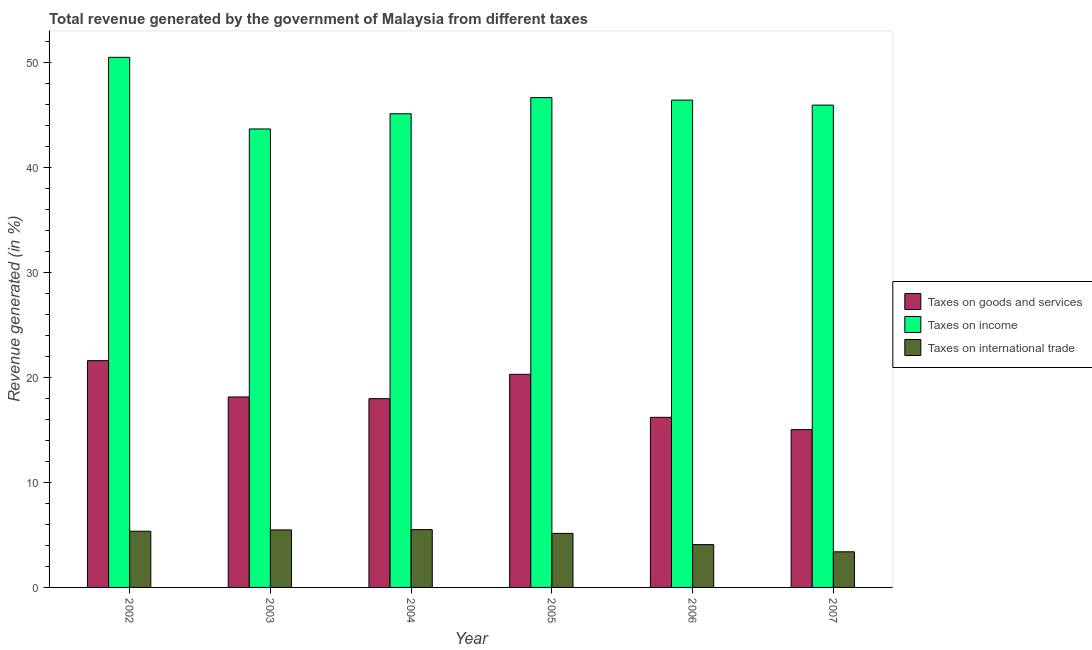How many different coloured bars are there?
Your answer should be very brief. 3. Are the number of bars per tick equal to the number of legend labels?
Your answer should be compact. Yes. Are the number of bars on each tick of the X-axis equal?
Provide a short and direct response. Yes. How many bars are there on the 1st tick from the left?
Your answer should be compact. 3. How many bars are there on the 5th tick from the right?
Offer a terse response. 3. What is the percentage of revenue generated by taxes on income in 2003?
Provide a succinct answer. 43.67. Across all years, what is the maximum percentage of revenue generated by taxes on income?
Your response must be concise. 50.49. Across all years, what is the minimum percentage of revenue generated by taxes on goods and services?
Ensure brevity in your answer.  15.03. In which year was the percentage of revenue generated by taxes on income maximum?
Your answer should be very brief. 2002. In which year was the percentage of revenue generated by taxes on income minimum?
Your response must be concise. 2003. What is the total percentage of revenue generated by taxes on goods and services in the graph?
Your answer should be very brief. 109.26. What is the difference between the percentage of revenue generated by taxes on goods and services in 2005 and that in 2006?
Offer a very short reply. 4.1. What is the difference between the percentage of revenue generated by tax on international trade in 2005 and the percentage of revenue generated by taxes on income in 2002?
Make the answer very short. -0.21. What is the average percentage of revenue generated by taxes on goods and services per year?
Your answer should be very brief. 18.21. In how many years, is the percentage of revenue generated by tax on international trade greater than 34 %?
Make the answer very short. 0. What is the ratio of the percentage of revenue generated by taxes on income in 2003 to that in 2005?
Ensure brevity in your answer.  0.94. Is the difference between the percentage of revenue generated by tax on international trade in 2003 and 2006 greater than the difference between the percentage of revenue generated by taxes on goods and services in 2003 and 2006?
Make the answer very short. No. What is the difference between the highest and the second highest percentage of revenue generated by taxes on income?
Your response must be concise. 3.84. What is the difference between the highest and the lowest percentage of revenue generated by taxes on goods and services?
Keep it short and to the point. 6.57. What does the 1st bar from the left in 2002 represents?
Your answer should be compact. Taxes on goods and services. What does the 1st bar from the right in 2003 represents?
Your answer should be very brief. Taxes on international trade. Is it the case that in every year, the sum of the percentage of revenue generated by taxes on goods and services and percentage of revenue generated by taxes on income is greater than the percentage of revenue generated by tax on international trade?
Give a very brief answer. Yes. How many bars are there?
Provide a succinct answer. 18. Are all the bars in the graph horizontal?
Your response must be concise. No. How many years are there in the graph?
Offer a terse response. 6. What is the difference between two consecutive major ticks on the Y-axis?
Offer a terse response. 10. Are the values on the major ticks of Y-axis written in scientific E-notation?
Make the answer very short. No. Does the graph contain grids?
Your answer should be very brief. No. How many legend labels are there?
Keep it short and to the point. 3. How are the legend labels stacked?
Provide a short and direct response. Vertical. What is the title of the graph?
Your answer should be very brief. Total revenue generated by the government of Malaysia from different taxes. What is the label or title of the X-axis?
Ensure brevity in your answer.  Year. What is the label or title of the Y-axis?
Your response must be concise. Revenue generated (in %). What is the Revenue generated (in %) of Taxes on goods and services in 2002?
Give a very brief answer. 21.6. What is the Revenue generated (in %) of Taxes on income in 2002?
Ensure brevity in your answer.  50.49. What is the Revenue generated (in %) of Taxes on international trade in 2002?
Provide a short and direct response. 5.35. What is the Revenue generated (in %) of Taxes on goods and services in 2003?
Offer a very short reply. 18.14. What is the Revenue generated (in %) in Taxes on income in 2003?
Your answer should be very brief. 43.67. What is the Revenue generated (in %) in Taxes on international trade in 2003?
Keep it short and to the point. 5.48. What is the Revenue generated (in %) of Taxes on goods and services in 2004?
Ensure brevity in your answer.  17.98. What is the Revenue generated (in %) in Taxes on income in 2004?
Provide a short and direct response. 45.12. What is the Revenue generated (in %) in Taxes on international trade in 2004?
Offer a terse response. 5.51. What is the Revenue generated (in %) in Taxes on goods and services in 2005?
Your answer should be compact. 20.3. What is the Revenue generated (in %) of Taxes on income in 2005?
Provide a succinct answer. 46.66. What is the Revenue generated (in %) of Taxes on international trade in 2005?
Your answer should be very brief. 5.15. What is the Revenue generated (in %) in Taxes on goods and services in 2006?
Offer a terse response. 16.2. What is the Revenue generated (in %) of Taxes on income in 2006?
Your answer should be compact. 46.42. What is the Revenue generated (in %) of Taxes on international trade in 2006?
Offer a very short reply. 4.08. What is the Revenue generated (in %) in Taxes on goods and services in 2007?
Give a very brief answer. 15.03. What is the Revenue generated (in %) in Taxes on income in 2007?
Keep it short and to the point. 45.94. What is the Revenue generated (in %) of Taxes on international trade in 2007?
Make the answer very short. 3.39. Across all years, what is the maximum Revenue generated (in %) in Taxes on goods and services?
Make the answer very short. 21.6. Across all years, what is the maximum Revenue generated (in %) in Taxes on income?
Provide a succinct answer. 50.49. Across all years, what is the maximum Revenue generated (in %) of Taxes on international trade?
Your response must be concise. 5.51. Across all years, what is the minimum Revenue generated (in %) in Taxes on goods and services?
Offer a very short reply. 15.03. Across all years, what is the minimum Revenue generated (in %) in Taxes on income?
Provide a short and direct response. 43.67. Across all years, what is the minimum Revenue generated (in %) in Taxes on international trade?
Your answer should be very brief. 3.39. What is the total Revenue generated (in %) in Taxes on goods and services in the graph?
Offer a terse response. 109.26. What is the total Revenue generated (in %) in Taxes on income in the graph?
Provide a short and direct response. 278.29. What is the total Revenue generated (in %) of Taxes on international trade in the graph?
Your answer should be very brief. 28.96. What is the difference between the Revenue generated (in %) in Taxes on goods and services in 2002 and that in 2003?
Your answer should be very brief. 3.46. What is the difference between the Revenue generated (in %) in Taxes on income in 2002 and that in 2003?
Keep it short and to the point. 6.82. What is the difference between the Revenue generated (in %) in Taxes on international trade in 2002 and that in 2003?
Offer a terse response. -0.13. What is the difference between the Revenue generated (in %) in Taxes on goods and services in 2002 and that in 2004?
Offer a terse response. 3.62. What is the difference between the Revenue generated (in %) of Taxes on income in 2002 and that in 2004?
Your answer should be compact. 5.38. What is the difference between the Revenue generated (in %) in Taxes on international trade in 2002 and that in 2004?
Your answer should be very brief. -0.15. What is the difference between the Revenue generated (in %) in Taxes on goods and services in 2002 and that in 2005?
Your answer should be very brief. 1.3. What is the difference between the Revenue generated (in %) in Taxes on income in 2002 and that in 2005?
Your answer should be compact. 3.84. What is the difference between the Revenue generated (in %) of Taxes on international trade in 2002 and that in 2005?
Offer a terse response. 0.21. What is the difference between the Revenue generated (in %) of Taxes on goods and services in 2002 and that in 2006?
Provide a succinct answer. 5.4. What is the difference between the Revenue generated (in %) of Taxes on income in 2002 and that in 2006?
Make the answer very short. 4.07. What is the difference between the Revenue generated (in %) of Taxes on international trade in 2002 and that in 2006?
Your answer should be compact. 1.27. What is the difference between the Revenue generated (in %) of Taxes on goods and services in 2002 and that in 2007?
Provide a short and direct response. 6.57. What is the difference between the Revenue generated (in %) in Taxes on income in 2002 and that in 2007?
Keep it short and to the point. 4.55. What is the difference between the Revenue generated (in %) of Taxes on international trade in 2002 and that in 2007?
Provide a short and direct response. 1.96. What is the difference between the Revenue generated (in %) of Taxes on goods and services in 2003 and that in 2004?
Offer a very short reply. 0.16. What is the difference between the Revenue generated (in %) in Taxes on income in 2003 and that in 2004?
Your response must be concise. -1.45. What is the difference between the Revenue generated (in %) of Taxes on international trade in 2003 and that in 2004?
Provide a short and direct response. -0.03. What is the difference between the Revenue generated (in %) of Taxes on goods and services in 2003 and that in 2005?
Offer a terse response. -2.16. What is the difference between the Revenue generated (in %) of Taxes on income in 2003 and that in 2005?
Provide a succinct answer. -2.99. What is the difference between the Revenue generated (in %) of Taxes on international trade in 2003 and that in 2005?
Keep it short and to the point. 0.33. What is the difference between the Revenue generated (in %) in Taxes on goods and services in 2003 and that in 2006?
Make the answer very short. 1.94. What is the difference between the Revenue generated (in %) of Taxes on income in 2003 and that in 2006?
Your response must be concise. -2.75. What is the difference between the Revenue generated (in %) in Taxes on international trade in 2003 and that in 2006?
Make the answer very short. 1.4. What is the difference between the Revenue generated (in %) in Taxes on goods and services in 2003 and that in 2007?
Your answer should be very brief. 3.11. What is the difference between the Revenue generated (in %) in Taxes on income in 2003 and that in 2007?
Offer a very short reply. -2.27. What is the difference between the Revenue generated (in %) of Taxes on international trade in 2003 and that in 2007?
Make the answer very short. 2.09. What is the difference between the Revenue generated (in %) in Taxes on goods and services in 2004 and that in 2005?
Your answer should be very brief. -2.32. What is the difference between the Revenue generated (in %) in Taxes on income in 2004 and that in 2005?
Your response must be concise. -1.54. What is the difference between the Revenue generated (in %) of Taxes on international trade in 2004 and that in 2005?
Ensure brevity in your answer.  0.36. What is the difference between the Revenue generated (in %) of Taxes on goods and services in 2004 and that in 2006?
Offer a terse response. 1.78. What is the difference between the Revenue generated (in %) of Taxes on income in 2004 and that in 2006?
Provide a succinct answer. -1.3. What is the difference between the Revenue generated (in %) of Taxes on international trade in 2004 and that in 2006?
Offer a terse response. 1.43. What is the difference between the Revenue generated (in %) of Taxes on goods and services in 2004 and that in 2007?
Give a very brief answer. 2.95. What is the difference between the Revenue generated (in %) of Taxes on income in 2004 and that in 2007?
Your answer should be very brief. -0.82. What is the difference between the Revenue generated (in %) of Taxes on international trade in 2004 and that in 2007?
Offer a terse response. 2.11. What is the difference between the Revenue generated (in %) in Taxes on goods and services in 2005 and that in 2006?
Your answer should be very brief. 4.1. What is the difference between the Revenue generated (in %) of Taxes on income in 2005 and that in 2006?
Keep it short and to the point. 0.24. What is the difference between the Revenue generated (in %) of Taxes on international trade in 2005 and that in 2006?
Your answer should be very brief. 1.07. What is the difference between the Revenue generated (in %) in Taxes on goods and services in 2005 and that in 2007?
Offer a terse response. 5.27. What is the difference between the Revenue generated (in %) of Taxes on income in 2005 and that in 2007?
Make the answer very short. 0.72. What is the difference between the Revenue generated (in %) of Taxes on international trade in 2005 and that in 2007?
Keep it short and to the point. 1.75. What is the difference between the Revenue generated (in %) in Taxes on goods and services in 2006 and that in 2007?
Offer a very short reply. 1.17. What is the difference between the Revenue generated (in %) of Taxes on income in 2006 and that in 2007?
Your answer should be compact. 0.48. What is the difference between the Revenue generated (in %) in Taxes on international trade in 2006 and that in 2007?
Provide a short and direct response. 0.69. What is the difference between the Revenue generated (in %) in Taxes on goods and services in 2002 and the Revenue generated (in %) in Taxes on income in 2003?
Your answer should be very brief. -22.07. What is the difference between the Revenue generated (in %) in Taxes on goods and services in 2002 and the Revenue generated (in %) in Taxes on international trade in 2003?
Provide a short and direct response. 16.12. What is the difference between the Revenue generated (in %) of Taxes on income in 2002 and the Revenue generated (in %) of Taxes on international trade in 2003?
Provide a succinct answer. 45.01. What is the difference between the Revenue generated (in %) in Taxes on goods and services in 2002 and the Revenue generated (in %) in Taxes on income in 2004?
Provide a short and direct response. -23.52. What is the difference between the Revenue generated (in %) in Taxes on goods and services in 2002 and the Revenue generated (in %) in Taxes on international trade in 2004?
Provide a short and direct response. 16.09. What is the difference between the Revenue generated (in %) of Taxes on income in 2002 and the Revenue generated (in %) of Taxes on international trade in 2004?
Offer a very short reply. 44.98. What is the difference between the Revenue generated (in %) of Taxes on goods and services in 2002 and the Revenue generated (in %) of Taxes on income in 2005?
Offer a very short reply. -25.06. What is the difference between the Revenue generated (in %) of Taxes on goods and services in 2002 and the Revenue generated (in %) of Taxes on international trade in 2005?
Your answer should be very brief. 16.45. What is the difference between the Revenue generated (in %) in Taxes on income in 2002 and the Revenue generated (in %) in Taxes on international trade in 2005?
Keep it short and to the point. 45.35. What is the difference between the Revenue generated (in %) of Taxes on goods and services in 2002 and the Revenue generated (in %) of Taxes on income in 2006?
Your response must be concise. -24.82. What is the difference between the Revenue generated (in %) of Taxes on goods and services in 2002 and the Revenue generated (in %) of Taxes on international trade in 2006?
Your response must be concise. 17.52. What is the difference between the Revenue generated (in %) in Taxes on income in 2002 and the Revenue generated (in %) in Taxes on international trade in 2006?
Offer a terse response. 46.41. What is the difference between the Revenue generated (in %) in Taxes on goods and services in 2002 and the Revenue generated (in %) in Taxes on income in 2007?
Make the answer very short. -24.34. What is the difference between the Revenue generated (in %) in Taxes on goods and services in 2002 and the Revenue generated (in %) in Taxes on international trade in 2007?
Offer a very short reply. 18.21. What is the difference between the Revenue generated (in %) in Taxes on income in 2002 and the Revenue generated (in %) in Taxes on international trade in 2007?
Offer a terse response. 47.1. What is the difference between the Revenue generated (in %) of Taxes on goods and services in 2003 and the Revenue generated (in %) of Taxes on income in 2004?
Make the answer very short. -26.97. What is the difference between the Revenue generated (in %) of Taxes on goods and services in 2003 and the Revenue generated (in %) of Taxes on international trade in 2004?
Provide a succinct answer. 12.63. What is the difference between the Revenue generated (in %) in Taxes on income in 2003 and the Revenue generated (in %) in Taxes on international trade in 2004?
Make the answer very short. 38.16. What is the difference between the Revenue generated (in %) of Taxes on goods and services in 2003 and the Revenue generated (in %) of Taxes on income in 2005?
Provide a short and direct response. -28.51. What is the difference between the Revenue generated (in %) of Taxes on goods and services in 2003 and the Revenue generated (in %) of Taxes on international trade in 2005?
Give a very brief answer. 13. What is the difference between the Revenue generated (in %) in Taxes on income in 2003 and the Revenue generated (in %) in Taxes on international trade in 2005?
Ensure brevity in your answer.  38.52. What is the difference between the Revenue generated (in %) of Taxes on goods and services in 2003 and the Revenue generated (in %) of Taxes on income in 2006?
Provide a succinct answer. -28.28. What is the difference between the Revenue generated (in %) in Taxes on goods and services in 2003 and the Revenue generated (in %) in Taxes on international trade in 2006?
Your answer should be compact. 14.06. What is the difference between the Revenue generated (in %) in Taxes on income in 2003 and the Revenue generated (in %) in Taxes on international trade in 2006?
Offer a very short reply. 39.59. What is the difference between the Revenue generated (in %) of Taxes on goods and services in 2003 and the Revenue generated (in %) of Taxes on income in 2007?
Keep it short and to the point. -27.8. What is the difference between the Revenue generated (in %) in Taxes on goods and services in 2003 and the Revenue generated (in %) in Taxes on international trade in 2007?
Offer a very short reply. 14.75. What is the difference between the Revenue generated (in %) of Taxes on income in 2003 and the Revenue generated (in %) of Taxes on international trade in 2007?
Your response must be concise. 40.27. What is the difference between the Revenue generated (in %) in Taxes on goods and services in 2004 and the Revenue generated (in %) in Taxes on income in 2005?
Provide a succinct answer. -28.67. What is the difference between the Revenue generated (in %) in Taxes on goods and services in 2004 and the Revenue generated (in %) in Taxes on international trade in 2005?
Your response must be concise. 12.84. What is the difference between the Revenue generated (in %) of Taxes on income in 2004 and the Revenue generated (in %) of Taxes on international trade in 2005?
Ensure brevity in your answer.  39.97. What is the difference between the Revenue generated (in %) in Taxes on goods and services in 2004 and the Revenue generated (in %) in Taxes on income in 2006?
Your response must be concise. -28.44. What is the difference between the Revenue generated (in %) in Taxes on goods and services in 2004 and the Revenue generated (in %) in Taxes on international trade in 2006?
Your answer should be very brief. 13.9. What is the difference between the Revenue generated (in %) of Taxes on income in 2004 and the Revenue generated (in %) of Taxes on international trade in 2006?
Give a very brief answer. 41.04. What is the difference between the Revenue generated (in %) in Taxes on goods and services in 2004 and the Revenue generated (in %) in Taxes on income in 2007?
Give a very brief answer. -27.96. What is the difference between the Revenue generated (in %) in Taxes on goods and services in 2004 and the Revenue generated (in %) in Taxes on international trade in 2007?
Give a very brief answer. 14.59. What is the difference between the Revenue generated (in %) of Taxes on income in 2004 and the Revenue generated (in %) of Taxes on international trade in 2007?
Provide a succinct answer. 41.72. What is the difference between the Revenue generated (in %) in Taxes on goods and services in 2005 and the Revenue generated (in %) in Taxes on income in 2006?
Your answer should be very brief. -26.12. What is the difference between the Revenue generated (in %) of Taxes on goods and services in 2005 and the Revenue generated (in %) of Taxes on international trade in 2006?
Provide a short and direct response. 16.22. What is the difference between the Revenue generated (in %) of Taxes on income in 2005 and the Revenue generated (in %) of Taxes on international trade in 2006?
Keep it short and to the point. 42.58. What is the difference between the Revenue generated (in %) in Taxes on goods and services in 2005 and the Revenue generated (in %) in Taxes on income in 2007?
Make the answer very short. -25.64. What is the difference between the Revenue generated (in %) in Taxes on goods and services in 2005 and the Revenue generated (in %) in Taxes on international trade in 2007?
Ensure brevity in your answer.  16.91. What is the difference between the Revenue generated (in %) of Taxes on income in 2005 and the Revenue generated (in %) of Taxes on international trade in 2007?
Provide a succinct answer. 43.26. What is the difference between the Revenue generated (in %) in Taxes on goods and services in 2006 and the Revenue generated (in %) in Taxes on income in 2007?
Offer a very short reply. -29.74. What is the difference between the Revenue generated (in %) in Taxes on goods and services in 2006 and the Revenue generated (in %) in Taxes on international trade in 2007?
Ensure brevity in your answer.  12.81. What is the difference between the Revenue generated (in %) of Taxes on income in 2006 and the Revenue generated (in %) of Taxes on international trade in 2007?
Provide a short and direct response. 43.02. What is the average Revenue generated (in %) of Taxes on goods and services per year?
Ensure brevity in your answer.  18.21. What is the average Revenue generated (in %) of Taxes on income per year?
Provide a succinct answer. 46.38. What is the average Revenue generated (in %) of Taxes on international trade per year?
Your answer should be very brief. 4.83. In the year 2002, what is the difference between the Revenue generated (in %) of Taxes on goods and services and Revenue generated (in %) of Taxes on income?
Your answer should be very brief. -28.89. In the year 2002, what is the difference between the Revenue generated (in %) in Taxes on goods and services and Revenue generated (in %) in Taxes on international trade?
Make the answer very short. 16.25. In the year 2002, what is the difference between the Revenue generated (in %) in Taxes on income and Revenue generated (in %) in Taxes on international trade?
Your answer should be compact. 45.14. In the year 2003, what is the difference between the Revenue generated (in %) in Taxes on goods and services and Revenue generated (in %) in Taxes on income?
Offer a very short reply. -25.53. In the year 2003, what is the difference between the Revenue generated (in %) of Taxes on goods and services and Revenue generated (in %) of Taxes on international trade?
Your response must be concise. 12.66. In the year 2003, what is the difference between the Revenue generated (in %) of Taxes on income and Revenue generated (in %) of Taxes on international trade?
Keep it short and to the point. 38.19. In the year 2004, what is the difference between the Revenue generated (in %) in Taxes on goods and services and Revenue generated (in %) in Taxes on income?
Your response must be concise. -27.13. In the year 2004, what is the difference between the Revenue generated (in %) in Taxes on goods and services and Revenue generated (in %) in Taxes on international trade?
Ensure brevity in your answer.  12.47. In the year 2004, what is the difference between the Revenue generated (in %) of Taxes on income and Revenue generated (in %) of Taxes on international trade?
Give a very brief answer. 39.61. In the year 2005, what is the difference between the Revenue generated (in %) of Taxes on goods and services and Revenue generated (in %) of Taxes on income?
Your response must be concise. -26.35. In the year 2005, what is the difference between the Revenue generated (in %) of Taxes on goods and services and Revenue generated (in %) of Taxes on international trade?
Your response must be concise. 15.15. In the year 2005, what is the difference between the Revenue generated (in %) of Taxes on income and Revenue generated (in %) of Taxes on international trade?
Make the answer very short. 41.51. In the year 2006, what is the difference between the Revenue generated (in %) of Taxes on goods and services and Revenue generated (in %) of Taxes on income?
Give a very brief answer. -30.21. In the year 2006, what is the difference between the Revenue generated (in %) in Taxes on goods and services and Revenue generated (in %) in Taxes on international trade?
Provide a succinct answer. 12.12. In the year 2006, what is the difference between the Revenue generated (in %) in Taxes on income and Revenue generated (in %) in Taxes on international trade?
Provide a succinct answer. 42.34. In the year 2007, what is the difference between the Revenue generated (in %) of Taxes on goods and services and Revenue generated (in %) of Taxes on income?
Give a very brief answer. -30.91. In the year 2007, what is the difference between the Revenue generated (in %) of Taxes on goods and services and Revenue generated (in %) of Taxes on international trade?
Offer a very short reply. 11.64. In the year 2007, what is the difference between the Revenue generated (in %) of Taxes on income and Revenue generated (in %) of Taxes on international trade?
Offer a very short reply. 42.55. What is the ratio of the Revenue generated (in %) in Taxes on goods and services in 2002 to that in 2003?
Ensure brevity in your answer.  1.19. What is the ratio of the Revenue generated (in %) in Taxes on income in 2002 to that in 2003?
Your answer should be very brief. 1.16. What is the ratio of the Revenue generated (in %) of Taxes on international trade in 2002 to that in 2003?
Provide a short and direct response. 0.98. What is the ratio of the Revenue generated (in %) of Taxes on goods and services in 2002 to that in 2004?
Your answer should be very brief. 1.2. What is the ratio of the Revenue generated (in %) in Taxes on income in 2002 to that in 2004?
Give a very brief answer. 1.12. What is the ratio of the Revenue generated (in %) of Taxes on international trade in 2002 to that in 2004?
Your answer should be very brief. 0.97. What is the ratio of the Revenue generated (in %) in Taxes on goods and services in 2002 to that in 2005?
Give a very brief answer. 1.06. What is the ratio of the Revenue generated (in %) of Taxes on income in 2002 to that in 2005?
Your answer should be very brief. 1.08. What is the ratio of the Revenue generated (in %) in Taxes on international trade in 2002 to that in 2005?
Your answer should be compact. 1.04. What is the ratio of the Revenue generated (in %) of Taxes on goods and services in 2002 to that in 2006?
Ensure brevity in your answer.  1.33. What is the ratio of the Revenue generated (in %) in Taxes on income in 2002 to that in 2006?
Give a very brief answer. 1.09. What is the ratio of the Revenue generated (in %) of Taxes on international trade in 2002 to that in 2006?
Offer a very short reply. 1.31. What is the ratio of the Revenue generated (in %) of Taxes on goods and services in 2002 to that in 2007?
Give a very brief answer. 1.44. What is the ratio of the Revenue generated (in %) of Taxes on income in 2002 to that in 2007?
Your answer should be very brief. 1.1. What is the ratio of the Revenue generated (in %) of Taxes on international trade in 2002 to that in 2007?
Make the answer very short. 1.58. What is the ratio of the Revenue generated (in %) of Taxes on goods and services in 2003 to that in 2004?
Offer a terse response. 1.01. What is the ratio of the Revenue generated (in %) of Taxes on income in 2003 to that in 2004?
Make the answer very short. 0.97. What is the ratio of the Revenue generated (in %) in Taxes on goods and services in 2003 to that in 2005?
Your answer should be very brief. 0.89. What is the ratio of the Revenue generated (in %) in Taxes on income in 2003 to that in 2005?
Keep it short and to the point. 0.94. What is the ratio of the Revenue generated (in %) of Taxes on international trade in 2003 to that in 2005?
Keep it short and to the point. 1.06. What is the ratio of the Revenue generated (in %) in Taxes on goods and services in 2003 to that in 2006?
Give a very brief answer. 1.12. What is the ratio of the Revenue generated (in %) of Taxes on income in 2003 to that in 2006?
Give a very brief answer. 0.94. What is the ratio of the Revenue generated (in %) in Taxes on international trade in 2003 to that in 2006?
Offer a very short reply. 1.34. What is the ratio of the Revenue generated (in %) in Taxes on goods and services in 2003 to that in 2007?
Keep it short and to the point. 1.21. What is the ratio of the Revenue generated (in %) in Taxes on income in 2003 to that in 2007?
Offer a terse response. 0.95. What is the ratio of the Revenue generated (in %) of Taxes on international trade in 2003 to that in 2007?
Offer a terse response. 1.61. What is the ratio of the Revenue generated (in %) in Taxes on goods and services in 2004 to that in 2005?
Provide a succinct answer. 0.89. What is the ratio of the Revenue generated (in %) in Taxes on income in 2004 to that in 2005?
Your response must be concise. 0.97. What is the ratio of the Revenue generated (in %) in Taxes on international trade in 2004 to that in 2005?
Your response must be concise. 1.07. What is the ratio of the Revenue generated (in %) of Taxes on goods and services in 2004 to that in 2006?
Your response must be concise. 1.11. What is the ratio of the Revenue generated (in %) in Taxes on international trade in 2004 to that in 2006?
Your answer should be very brief. 1.35. What is the ratio of the Revenue generated (in %) in Taxes on goods and services in 2004 to that in 2007?
Keep it short and to the point. 1.2. What is the ratio of the Revenue generated (in %) of Taxes on income in 2004 to that in 2007?
Provide a short and direct response. 0.98. What is the ratio of the Revenue generated (in %) in Taxes on international trade in 2004 to that in 2007?
Make the answer very short. 1.62. What is the ratio of the Revenue generated (in %) in Taxes on goods and services in 2005 to that in 2006?
Provide a succinct answer. 1.25. What is the ratio of the Revenue generated (in %) in Taxes on income in 2005 to that in 2006?
Provide a short and direct response. 1.01. What is the ratio of the Revenue generated (in %) of Taxes on international trade in 2005 to that in 2006?
Provide a short and direct response. 1.26. What is the ratio of the Revenue generated (in %) in Taxes on goods and services in 2005 to that in 2007?
Provide a succinct answer. 1.35. What is the ratio of the Revenue generated (in %) of Taxes on income in 2005 to that in 2007?
Offer a very short reply. 1.02. What is the ratio of the Revenue generated (in %) in Taxes on international trade in 2005 to that in 2007?
Your answer should be compact. 1.52. What is the ratio of the Revenue generated (in %) in Taxes on goods and services in 2006 to that in 2007?
Your answer should be very brief. 1.08. What is the ratio of the Revenue generated (in %) of Taxes on income in 2006 to that in 2007?
Provide a succinct answer. 1.01. What is the ratio of the Revenue generated (in %) in Taxes on international trade in 2006 to that in 2007?
Provide a short and direct response. 1.2. What is the difference between the highest and the second highest Revenue generated (in %) of Taxes on goods and services?
Make the answer very short. 1.3. What is the difference between the highest and the second highest Revenue generated (in %) in Taxes on income?
Give a very brief answer. 3.84. What is the difference between the highest and the second highest Revenue generated (in %) of Taxes on international trade?
Your answer should be compact. 0.03. What is the difference between the highest and the lowest Revenue generated (in %) of Taxes on goods and services?
Ensure brevity in your answer.  6.57. What is the difference between the highest and the lowest Revenue generated (in %) in Taxes on income?
Keep it short and to the point. 6.82. What is the difference between the highest and the lowest Revenue generated (in %) in Taxes on international trade?
Provide a succinct answer. 2.11. 